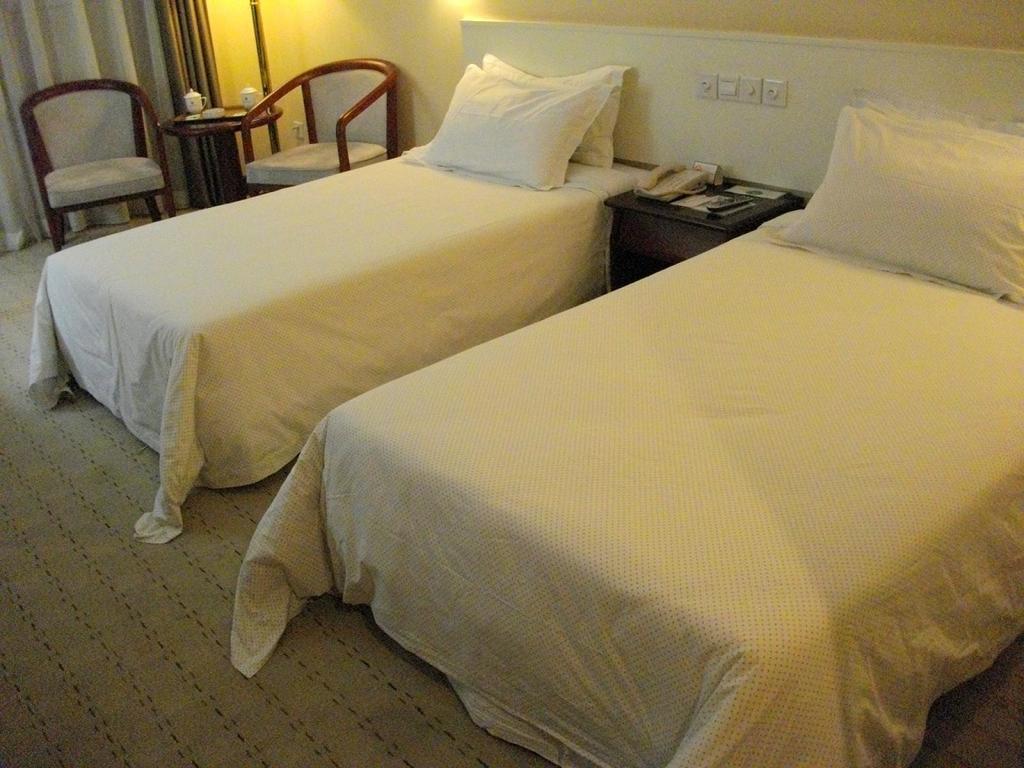Can you describe this image briefly? There are two beds covered with white blanket. These are the pillows placed on the bed. This is a small table with a telephone,remote and few things on it. This looks like a socket. There are two chairs. This is a teapoy with a tray of cups on it. These are the curtains hanging. 